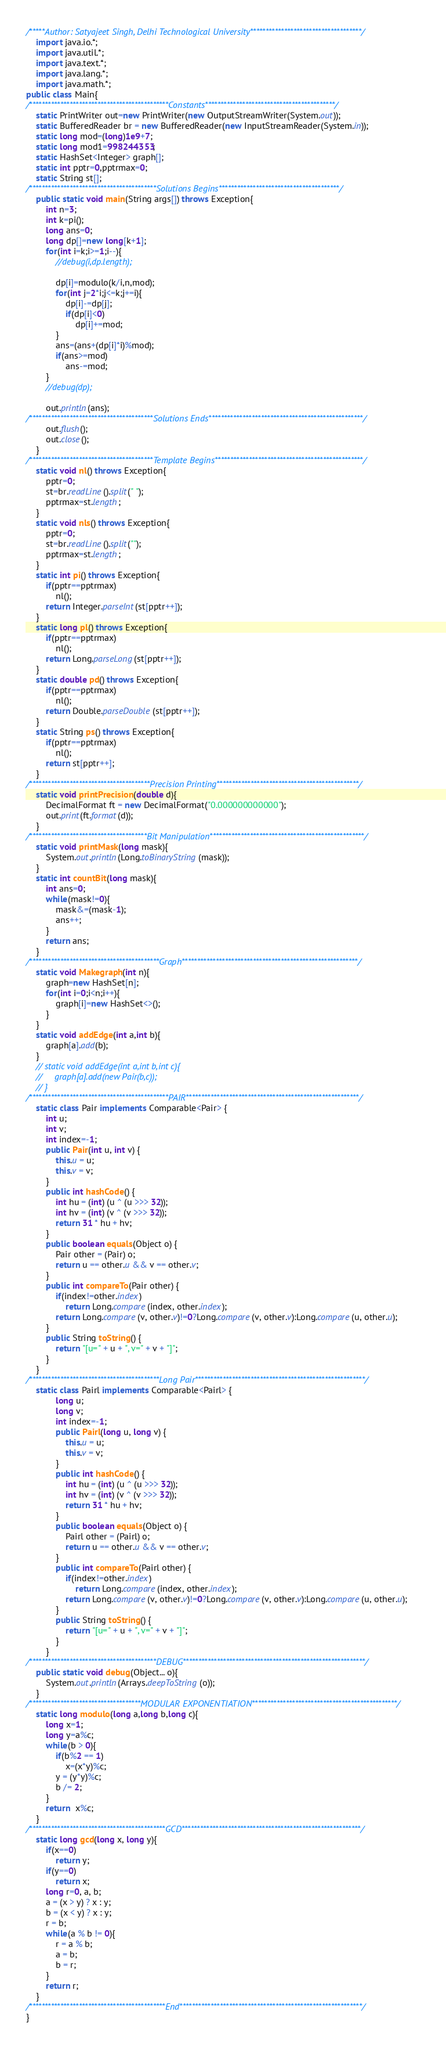Convert code to text. <code><loc_0><loc_0><loc_500><loc_500><_Java_>/*****Author: Satyajeet Singh, Delhi Technological University************************************/
    import java.io.*;
    import java.util.*;
    import java.text.*; 
    import java.lang.*;
    import java.math.*;
public class Main{
/*********************************************Constants******************************************/
    static PrintWriter out=new PrintWriter(new OutputStreamWriter(System.out));        
    static BufferedReader br = new BufferedReader(new InputStreamReader(System.in));
    static long mod=(long)1e9+7;
    static long mod1=998244353;
    static HashSet<Integer> graph[];
    static int pptr=0,pptrmax=0;
    static String st[];
/*****************************************Solutions Begins***************************************/
    public static void main(String args[]) throws Exception{
        int n=3;
        int k=pi();
        long ans=0;
        long dp[]=new long[k+1];
        for(int i=k;i>=1;i--){
            //debug(i,dp.length);

            dp[i]=modulo(k/i,n,mod);
            for(int j=2*i;j<=k;j+=i){
                dp[i]-=dp[j];
                if(dp[i]<0)
                    dp[i]+=mod;
            }
            ans=(ans+(dp[i]*i)%mod);
            if(ans>=mod)
                ans-=mod;
        }
        //debug(dp);

        out.println(ans);
/****************************************Solutions Ends**************************************************/
        out.flush();
        out.close();
    }
/****************************************Template Begins************************************************/
    static void nl() throws Exception{
        pptr=0;
        st=br.readLine().split(" ");
        pptrmax=st.length;
    }
    static void nls() throws Exception{
        pptr=0;
        st=br.readLine().split("");
        pptrmax=st.length;
    }
    static int pi() throws Exception{
        if(pptr==pptrmax)
            nl();
        return Integer.parseInt(st[pptr++]);
    }
    static long pl() throws Exception{
        if(pptr==pptrmax)
            nl();
        return Long.parseLong(st[pptr++]);
    }
    static double pd() throws Exception{
        if(pptr==pptrmax)
            nl();
        return Double.parseDouble(st[pptr++]);
    }
    static String ps() throws Exception{
        if(pptr==pptrmax)
            nl();
        return st[pptr++];
    }
/***************************************Precision Printing**********************************************/
    static void printPrecision(double d){
        DecimalFormat ft = new DecimalFormat("0.000000000000"); 
        out.print(ft.format(d));
    }
/**************************************Bit Manipulation**************************************************/
    static void printMask(long mask){
        System.out.println(Long.toBinaryString(mask));
    }
    static int countBit(long mask){
        int ans=0;
        while(mask!=0){
            mask&=(mask-1);
            ans++;
        }
        return ans;
    }
/******************************************Graph*********************************************************/
    static void Makegraph(int n){
        graph=new HashSet[n];
        for(int i=0;i<n;i++){
            graph[i]=new HashSet<>();
        }
    }
    static void addEdge(int a,int b){
        graph[a].add(b);
    }
    // static void addEdge(int a,int b,int c){
    //     graph[a].add(new Pair(b,c));
    // }    
/*********************************************PAIR********************************************************/
    static class Pair implements Comparable<Pair> {
        int u;
        int v;
        int index=-1;
        public Pair(int u, int v) {
            this.u = u;
            this.v = v;
        }
        public int hashCode() {
            int hu = (int) (u ^ (u >>> 32));
            int hv = (int) (v ^ (v >>> 32));
            return 31 * hu + hv;
        }
        public boolean equals(Object o) {
            Pair other = (Pair) o;
            return u == other.u && v == other.v;
        }
        public int compareTo(Pair other) {
            if(index!=other.index)
                return Long.compare(index, other.index);
            return Long.compare(v, other.v)!=0?Long.compare(v, other.v):Long.compare(u, other.u);
        }
        public String toString() {
            return "[u=" + u + ", v=" + v + "]";
        }
    }
/******************************************Long Pair*******************************************************/
    static class Pairl implements Comparable<Pairl> {
            long u;
            long v;
            int index=-1;
            public Pairl(long u, long v) {
                this.u = u;
                this.v = v;
            }
            public int hashCode() {
                int hu = (int) (u ^ (u >>> 32));
                int hv = (int) (v ^ (v >>> 32));
                return 31 * hu + hv;
            }
            public boolean equals(Object o) {
                Pairl other = (Pairl) o;
                return u == other.u && v == other.v;
            }
            public int compareTo(Pairl other) {
                if(index!=other.index)
                    return Long.compare(index, other.index);
                return Long.compare(v, other.v)!=0?Long.compare(v, other.v):Long.compare(u, other.u);
            }
            public String toString() {
                return "[u=" + u + ", v=" + v + "]";
            }
        }
/*****************************************DEBUG***********************************************************/
    public static void debug(Object... o){
        System.out.println(Arrays.deepToString(o));
    }
/************************************MODULAR EXPONENTIATION***********************************************/
    static long modulo(long a,long b,long c){
        long x=1;
        long y=a%c;
        while(b > 0){
            if(b%2 == 1)
                x=(x*y)%c;
            y = (y*y)%c;
            b /= 2;
        }
        return  x%c;
    }
/********************************************GCD**********************************************************/
    static long gcd(long x, long y){
        if(x==0)
            return y;
        if(y==0)
            return x;
        long r=0, a, b;
        a = (x > y) ? x : y; 
        b = (x < y) ? x : y;
        r = b;
        while(a % b != 0){
            r = a % b;
            a = b;
            b = r;
        }
        return r;
    }
/********************************************End***********************************************************/
}</code> 